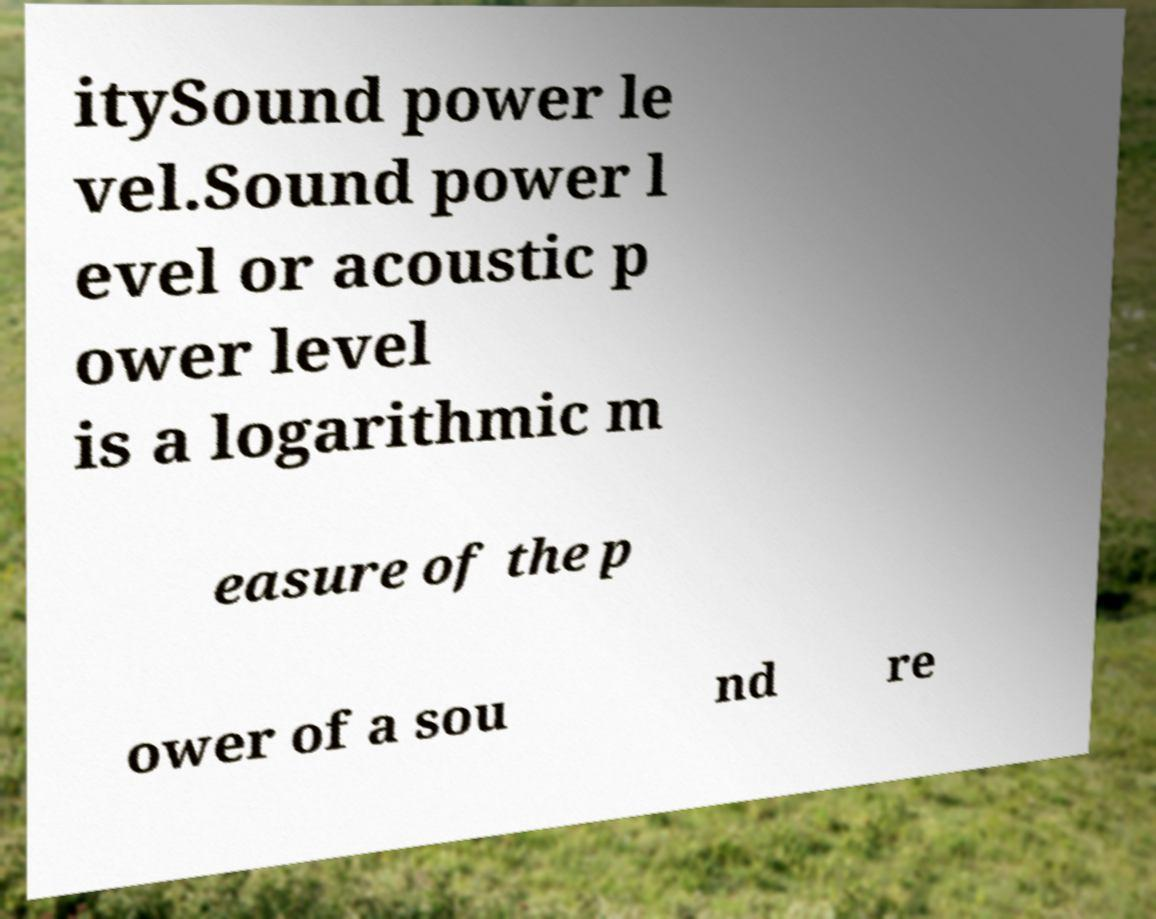There's text embedded in this image that I need extracted. Can you transcribe it verbatim? itySound power le vel.Sound power l evel or acoustic p ower level is a logarithmic m easure of the p ower of a sou nd re 